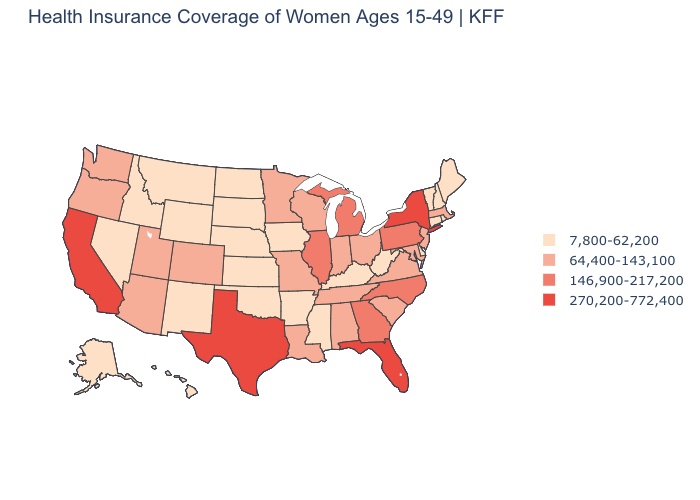Does Florida have the highest value in the South?
Short answer required. Yes. What is the highest value in the USA?
Concise answer only. 270,200-772,400. Does the first symbol in the legend represent the smallest category?
Quick response, please. Yes. Does New Hampshire have the lowest value in the USA?
Quick response, please. Yes. Does Texas have a higher value than California?
Answer briefly. No. Is the legend a continuous bar?
Keep it brief. No. Name the states that have a value in the range 146,900-217,200?
Quick response, please. Georgia, Illinois, Michigan, North Carolina, Pennsylvania. What is the value of Nebraska?
Be succinct. 7,800-62,200. What is the value of Kentucky?
Write a very short answer. 7,800-62,200. Does Wisconsin have the highest value in the USA?
Write a very short answer. No. What is the value of Virginia?
Write a very short answer. 64,400-143,100. Name the states that have a value in the range 7,800-62,200?
Quick response, please. Alaska, Arkansas, Connecticut, Delaware, Hawaii, Idaho, Iowa, Kansas, Kentucky, Maine, Mississippi, Montana, Nebraska, Nevada, New Hampshire, New Mexico, North Dakota, Oklahoma, Rhode Island, South Dakota, Vermont, West Virginia, Wyoming. What is the value of Massachusetts?
Answer briefly. 64,400-143,100. How many symbols are there in the legend?
Be succinct. 4. What is the value of Minnesota?
Write a very short answer. 64,400-143,100. 